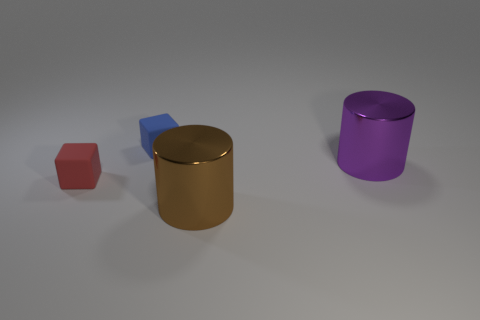Subtract all blue cubes. How many cubes are left? 1 Add 2 purple cylinders. How many objects exist? 6 Subtract all purple cylinders. How many cyan blocks are left? 0 Subtract all purple metallic cylinders. Subtract all tiny red things. How many objects are left? 2 Add 3 red rubber things. How many red rubber things are left? 4 Add 1 large green cylinders. How many large green cylinders exist? 1 Subtract 0 brown blocks. How many objects are left? 4 Subtract 1 cubes. How many cubes are left? 1 Subtract all red cylinders. Subtract all green spheres. How many cylinders are left? 2 